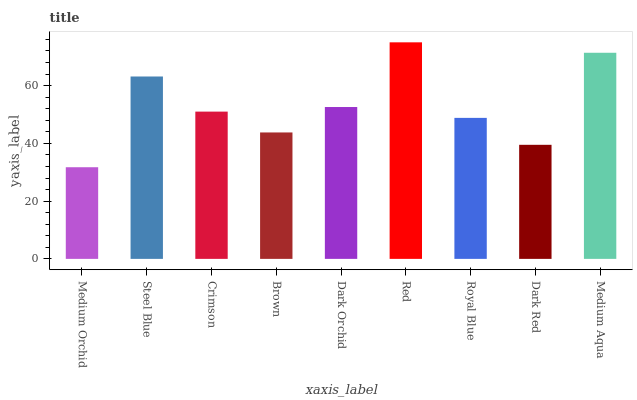Is Medium Orchid the minimum?
Answer yes or no. Yes. Is Red the maximum?
Answer yes or no. Yes. Is Steel Blue the minimum?
Answer yes or no. No. Is Steel Blue the maximum?
Answer yes or no. No. Is Steel Blue greater than Medium Orchid?
Answer yes or no. Yes. Is Medium Orchid less than Steel Blue?
Answer yes or no. Yes. Is Medium Orchid greater than Steel Blue?
Answer yes or no. No. Is Steel Blue less than Medium Orchid?
Answer yes or no. No. Is Crimson the high median?
Answer yes or no. Yes. Is Crimson the low median?
Answer yes or no. Yes. Is Medium Orchid the high median?
Answer yes or no. No. Is Dark Red the low median?
Answer yes or no. No. 